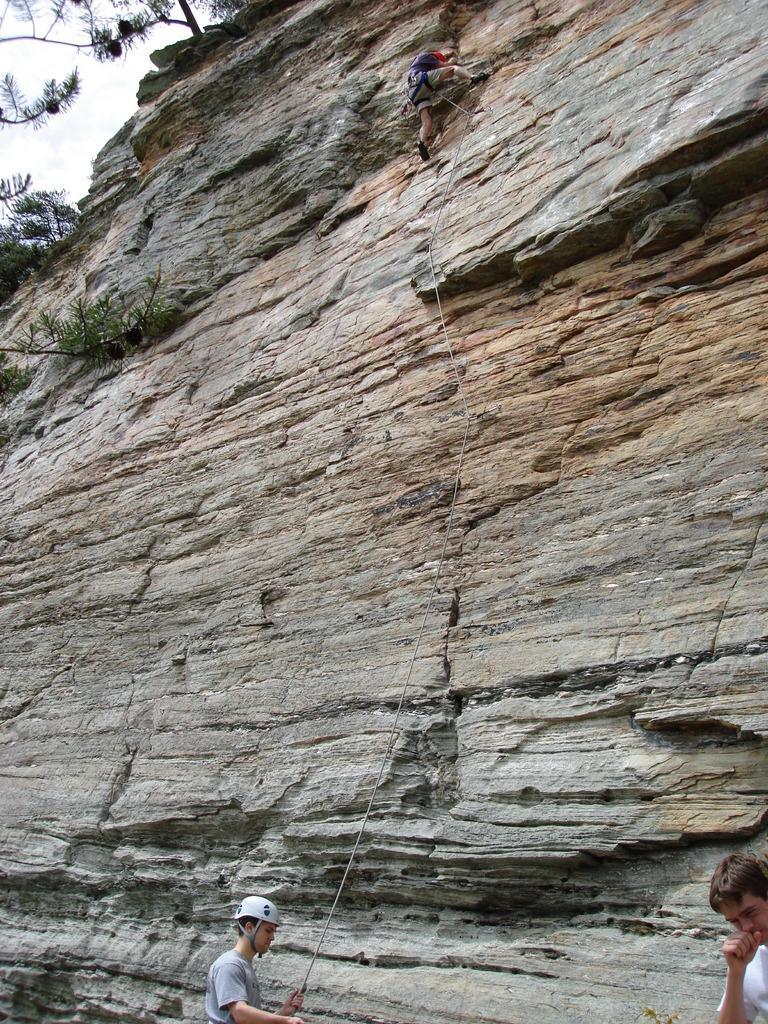In one or two sentences, can you explain what this image depicts? At the bottom of the picture, we see two men are standing. The man who is wearing the helmet is holding a rope. In front of him, we see the rock. At the top, we see the man is climbing the rock. On the left side, we see the trees. In the left top, we see the sky. 